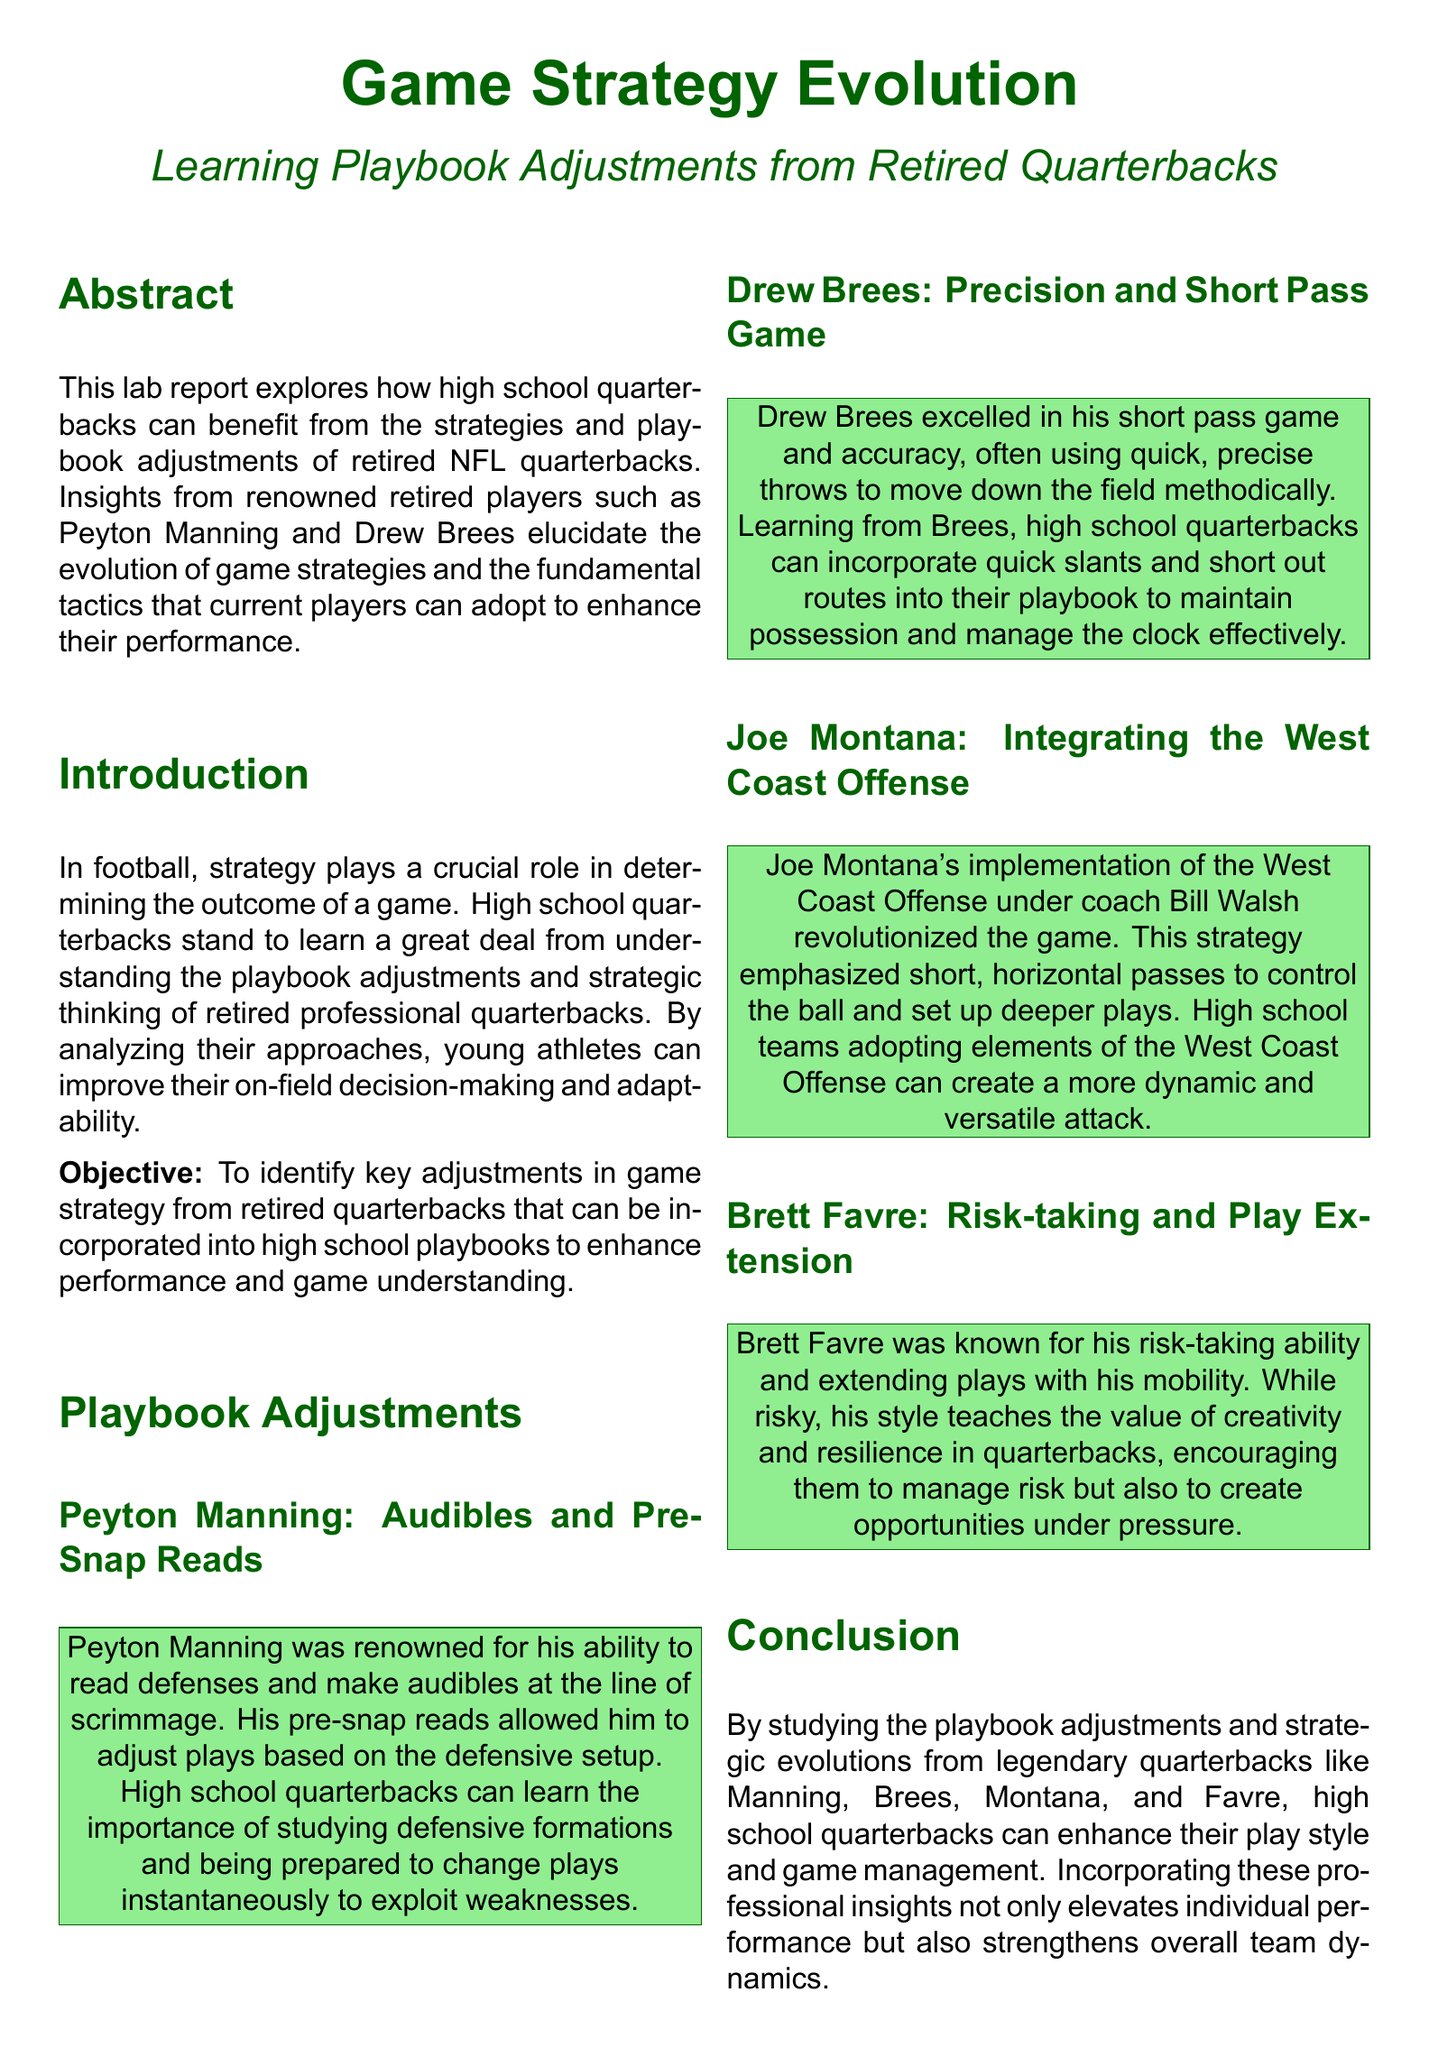What is the title of the lab report? The title conveys the main theme of the document, which is about the evolution of game strategies in football.
Answer: Game Strategy Evolution Who is the first retired quarterback mentioned in the Playbook Adjustments section? The first retired quarterback highlighted provides insights into playbook adjustments specifically related to reading defenses.
Answer: Peyton Manning What is one key theme emphasized by Drew Brees’ play style? The theme focuses on a specific tactic that enhances gameplay and scoring opportunities.
Answer: Precision and Short Pass Game Which offensive strategy did Joe Montana implement? The document details a particular revolutionary strategy associated with Montana that impacts gameplay.
Answer: West Coast Offense How many recommendations are listed in the conclusion? The recommendations provide actionable strategies for high school quarterbacks to improve their game and decision-making.
Answer: Four What is the purpose stated in the Objective section? The purpose outlines the main goal of analyzing retired quarterbacks' strategies for the benefit of current players.
Answer: To identify key adjustments in game strategy What is a specific recommendation for high school quarterbacks based on Brett Favre’s play style? The recommendation encourages a particular skill that enhances a quarterback's adaptability in uncertain game situations.
Answer: Hone ability to make quick, intelligent decisions under pressure Which year was the article by Manning published? The publication year of Manning's article provides context for the relevance of the strategies discussed.
Answer: 2011 What does the Abstract of the document emphasize? The Abstract summarizes the main focus and benefits outlined in the report for high school quarterbacks.
Answer: Learning Playbook Adjustments from Retired Quarterbacks 